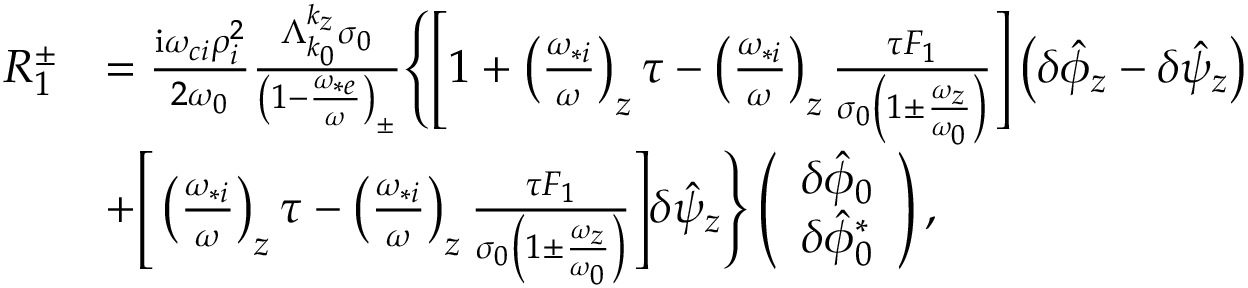Convert formula to latex. <formula><loc_0><loc_0><loc_500><loc_500>\begin{array} { r l } { R _ { 1 } ^ { \pm } } & { = \frac { i \omega _ { c i } \rho _ { i } ^ { 2 } } { 2 \omega _ { 0 } } \frac { \Lambda _ { k _ { 0 } } ^ { k _ { z } } \sigma _ { 0 } } { \left ( 1 - \frac { \omega _ { * e } } { \omega } \right ) _ { \pm } } \left \{ \left [ 1 + \left ( \frac { \omega _ { * i } } { \omega } \right ) _ { z } \tau - \left ( \frac { \omega _ { * i } } { \omega } \right ) _ { z } \frac { \tau F _ { 1 } } { \sigma _ { 0 } \left ( 1 \pm \frac { \omega _ { z } } { \omega _ { 0 } } \right ) } \right ] \left ( \delta \hat { \phi } _ { z } - \delta \hat { \psi } _ { z } \right ) } \\ & { + \left [ \left ( \frac { \omega _ { * i } } { \omega } \right ) _ { z } \tau - \left ( \frac { \omega _ { * i } } { \omega } \right ) _ { z } \frac { \tau F _ { 1 } } { \sigma _ { 0 } \left ( 1 \pm \frac { \omega _ { z } } { \omega _ { 0 } } \right ) } \right ] \delta \hat { \psi } _ { z } \right \} \left ( \begin{array} { c } { \delta \hat { \phi } _ { 0 } } \\ { \delta \hat { \phi } _ { 0 } ^ { * } } \end{array} \right ) , } \end{array}</formula> 